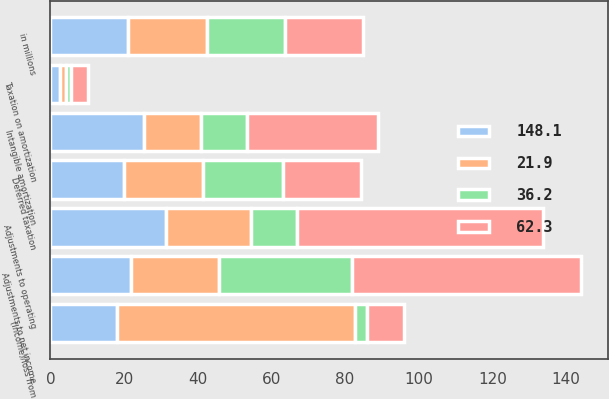Convert chart to OTSL. <chart><loc_0><loc_0><loc_500><loc_500><stacked_bar_chart><ecel><fcel>in millions<fcel>Intangible amortization<fcel>Adjustments to operating<fcel>Taxation on amortization<fcel>Deferred taxation<fcel>(Income)/loss from<fcel>Adjustments to net income<nl><fcel>36.2<fcel>21.2<fcel>12.6<fcel>12.6<fcel>1.6<fcel>21.8<fcel>3.4<fcel>36.2<nl><fcel>21.9<fcel>21.2<fcel>15.4<fcel>23<fcel>1.5<fcel>21.3<fcel>64.5<fcel>23.8<nl><fcel>148.1<fcel>21.2<fcel>25.5<fcel>31.4<fcel>2.6<fcel>20.1<fcel>18.1<fcel>21.9<nl><fcel>62.3<fcel>21.2<fcel>35.5<fcel>66.7<fcel>4.4<fcel>21.1<fcel>9.9<fcel>62.3<nl></chart> 